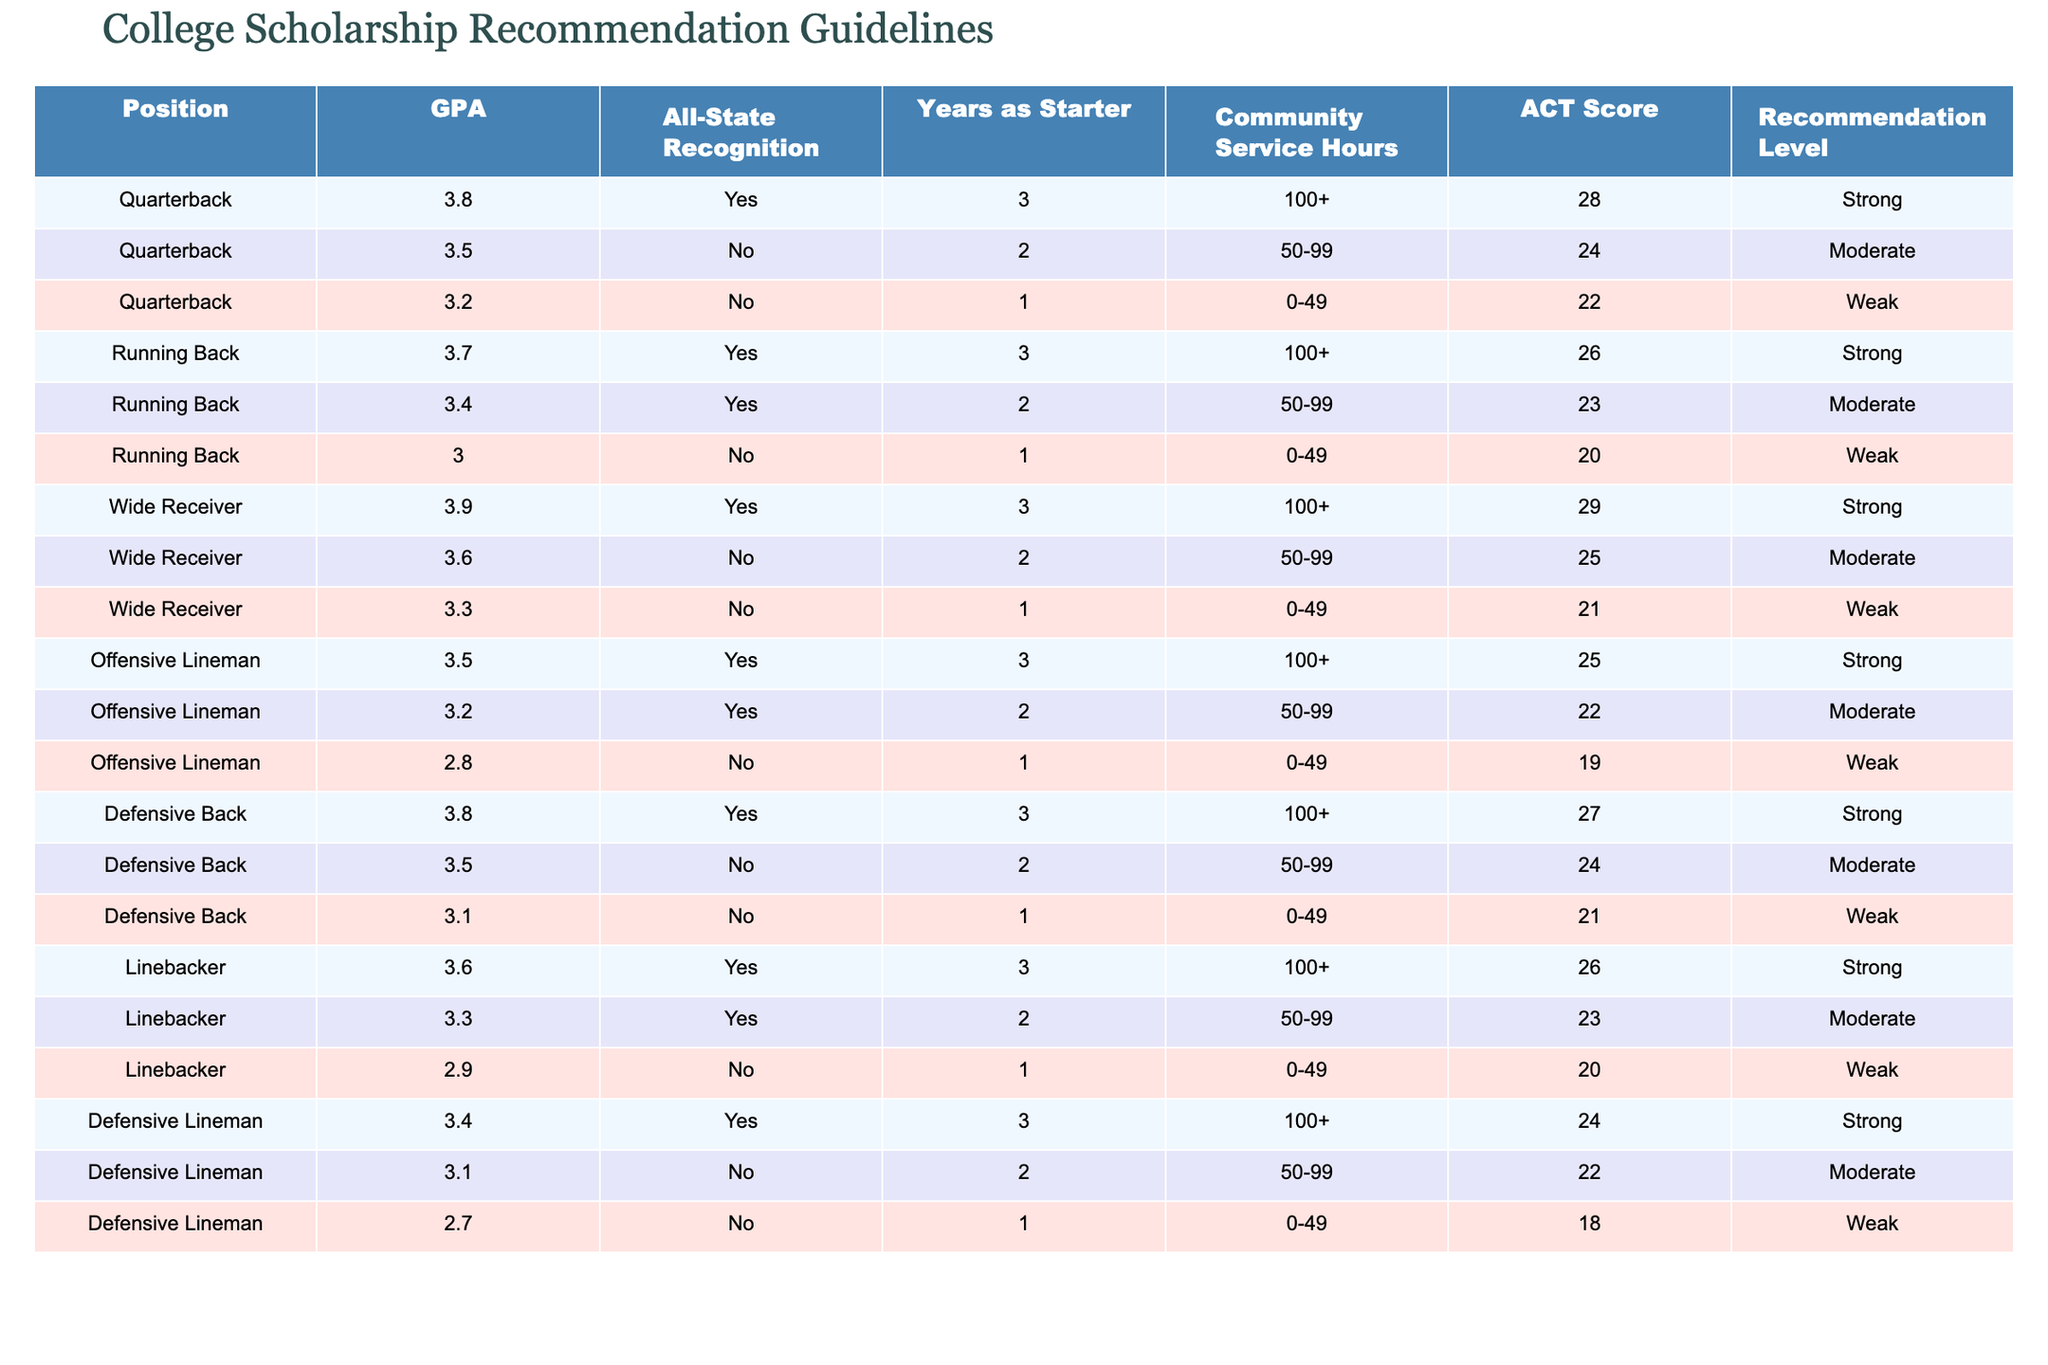What is the recommendation level for a Linebacker with a GPA of 3.6? Looking at the table, the row for Linebacker with a GPA of 3.6 shows that they have All-State recognition, 3 years as a starter, over 100 community service hours, and an ACT score of 26, which corresponds to a 'Strong' recommendation level.
Answer: Strong How many Offensive Linemen have a recommendation level of Weak? In the table, I scan through the Offensive Lineman section and find one player (the one with a GPA of 2.8, no All-State recognition, 1 year as a starter, 0-49 community service hours, and an ACT score of 19) who is categorized as 'Weak'. Therefore, there is one Offensive Lineman with a Weak recommendation.
Answer: 1 Is there any Quarterback with a recommendation level of Strong? Reviewing the Quarterback entries in the table, two players are listed with a recommendation level of 'Strong', both with GPAs above 3.5, significant community service hours, and decent ACT scores. Thus, the answer to whether there exists a Quarterback with a Strong recommendation level is true.
Answer: Yes What is the average ACT score of the players recommended as Moderate? I will first identify all players with a recommendation level of 'Moderate'. They include: Quarterback (ACT 24), Running Back (ACT 23), Wide Receiver (ACT 25), Offensive Lineman (ACT 22), Defensive Back (ACT 24), Linebacker (ACT 23), and Defensive Lineman (ACT 22). Next, I sum these scores (24 + 23 + 25 + 22 + 24 + 23 + 22) = 169. Then I count the number of moderate players, which is 7. Finally, the average is 169 / 7 ≈ 24.14.
Answer: 24.14 Which position has the highest number of players with Strong recommendation levels? By reviewing the table, it seems there are three positions with players recommended as Strong: Quarterback (2), Running Back (1), Wide Receiver (1), Offensive Lineman (1), Defensive Back (1), Linebacker (1), and Defensive Lineman (1). The only position with the maximum number of Strong recommendations is Quarterback, with 2 players.
Answer: Quarterback What is the total number of players listed in the table? To find the total number of players, I will simply count the rows in the table, which indicates 12 players in total across all positions.
Answer: 12 Is there a Defensive Lineman with a GPA of 3.4? Looking through the Defensive Lineman entries, I observe that there is only one player with a GPA of 3.4, who actually has a recommendation level of Strong. Hence, the answer is true that a Defensive Lineman with that GPA exists.
Answer: Yes 